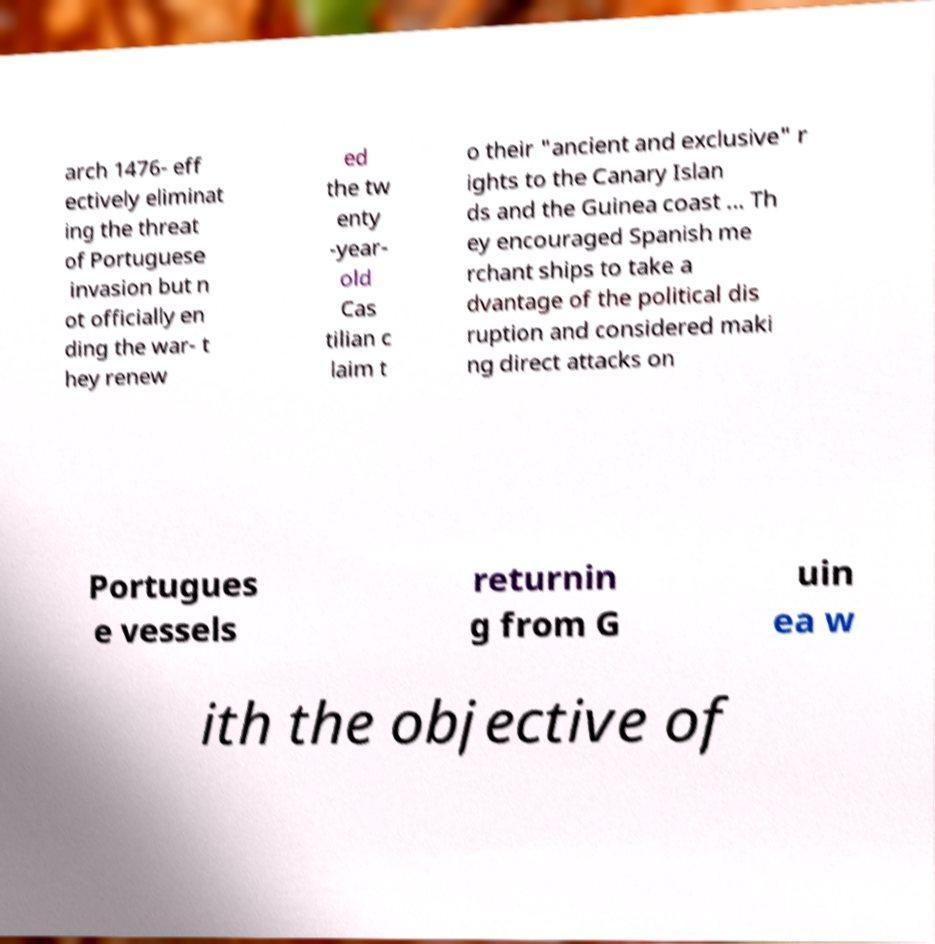Could you extract and type out the text from this image? arch 1476- eff ectively eliminat ing the threat of Portuguese invasion but n ot officially en ding the war- t hey renew ed the tw enty -year- old Cas tilian c laim t o their "ancient and exclusive" r ights to the Canary Islan ds and the Guinea coast ... Th ey encouraged Spanish me rchant ships to take a dvantage of the political dis ruption and considered maki ng direct attacks on Portugues e vessels returnin g from G uin ea w ith the objective of 